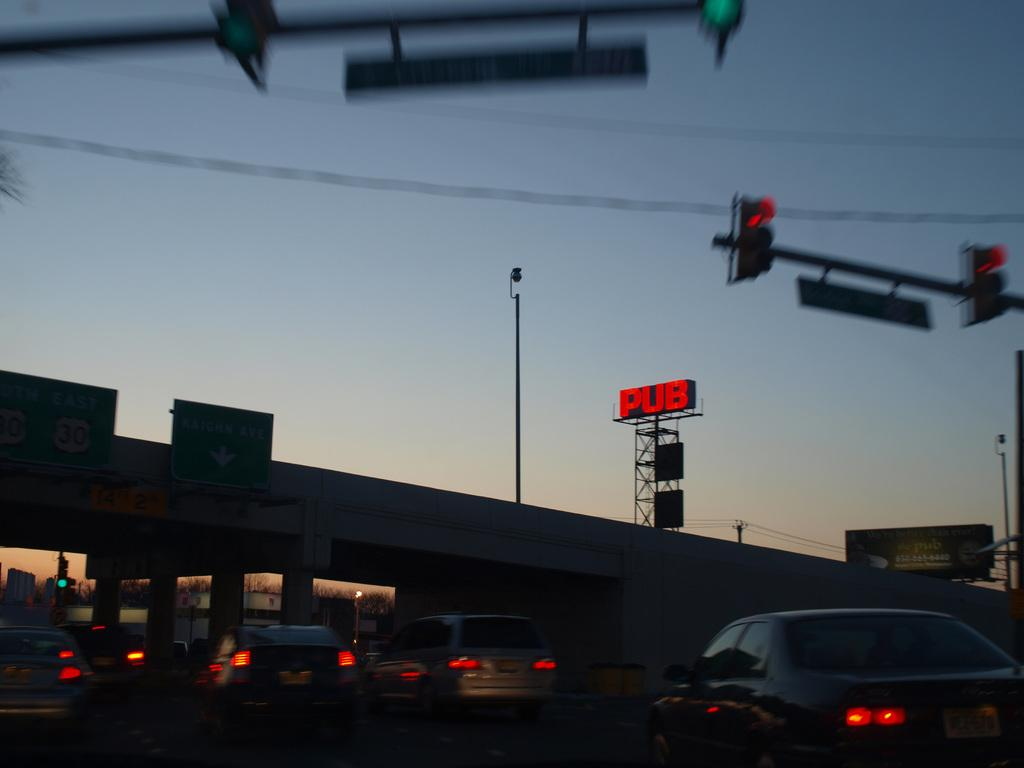<image>
Offer a succinct explanation of the picture presented. A busy street is shown with a bright red Pub sign above it. 